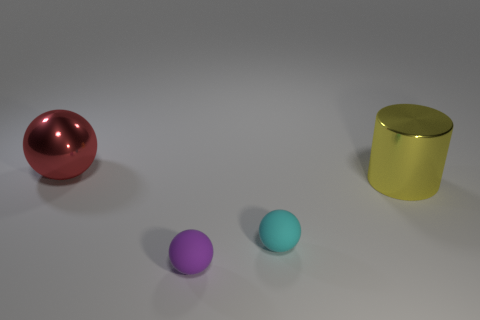There is a small matte object that is in front of the small cyan matte object; what is its shape?
Offer a terse response. Sphere. How many other objects have the same shape as the large red thing?
Offer a very short reply. 2. How many objects are big yellow objects or small blue blocks?
Your response must be concise. 1. What number of purple spheres are the same material as the big red object?
Your response must be concise. 0. Are there fewer rubber things than tiny purple spheres?
Provide a short and direct response. No. Are the big thing that is to the left of the yellow object and the large yellow cylinder made of the same material?
Your answer should be very brief. Yes. How many balls are red things or tiny cyan matte things?
Offer a very short reply. 2. What is the shape of the thing that is on the right side of the tiny purple matte sphere and in front of the yellow metallic cylinder?
Your response must be concise. Sphere. There is a big metallic thing behind the large metallic object that is in front of the big metal thing behind the big yellow shiny cylinder; what is its color?
Give a very brief answer. Red. Are there fewer yellow things that are in front of the big yellow shiny cylinder than tiny cyan rubber spheres?
Provide a succinct answer. Yes. 